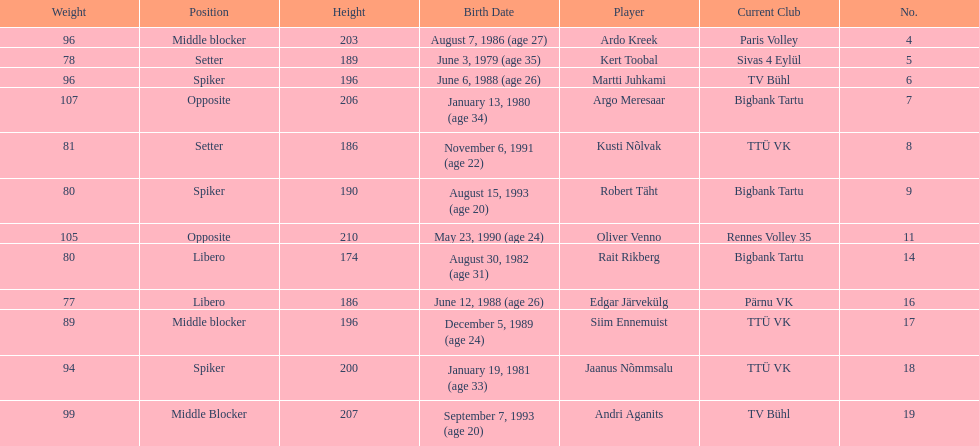Kert toobal is the oldest who is the next oldest player listed? Argo Meresaar. 